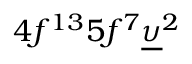Convert formula to latex. <formula><loc_0><loc_0><loc_500><loc_500>4 f ^ { 1 3 } 5 f ^ { 7 } \underline { \upsilon } ^ { 2 }</formula> 